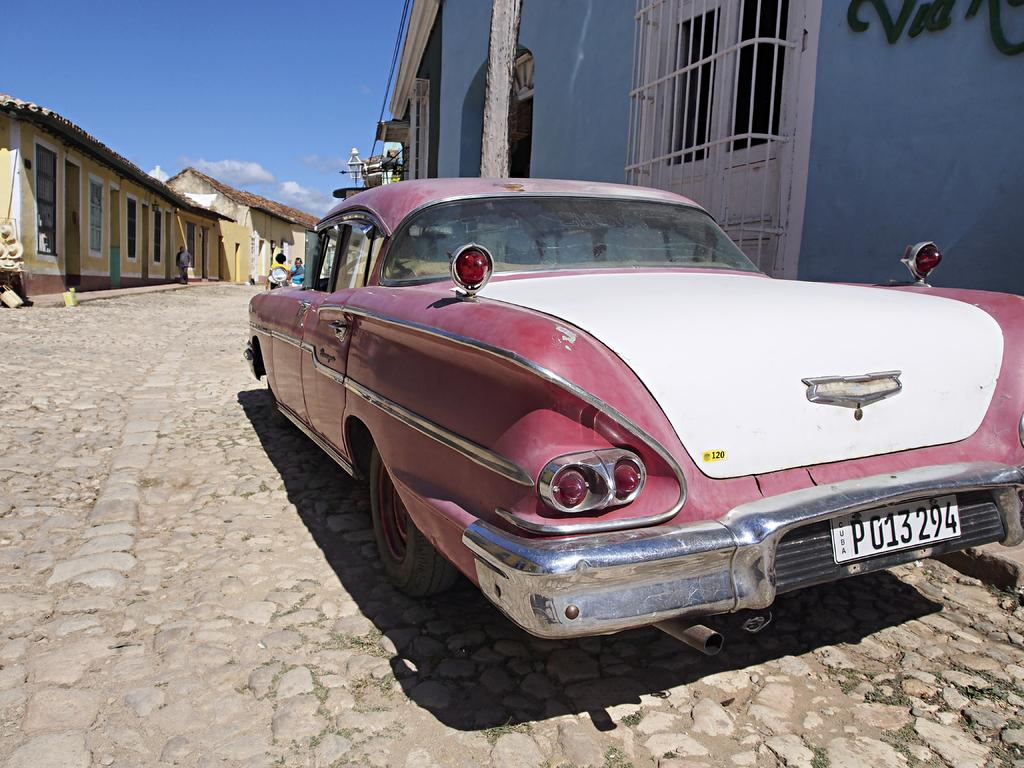What is the main subject of the image? The main subject of the image is a car. What structures can be seen in the image besides the car? There are sheds and a pole visible in the image. Are there any people present in the image? Yes, there are people in the image. What can be seen in the background of the image? The sky is visible in the background of the image. How many ducks are sitting on the knee of the person in the image? There are no ducks or knees visible in the image. What type of drain is present in the image? There is no drain present in the image. 